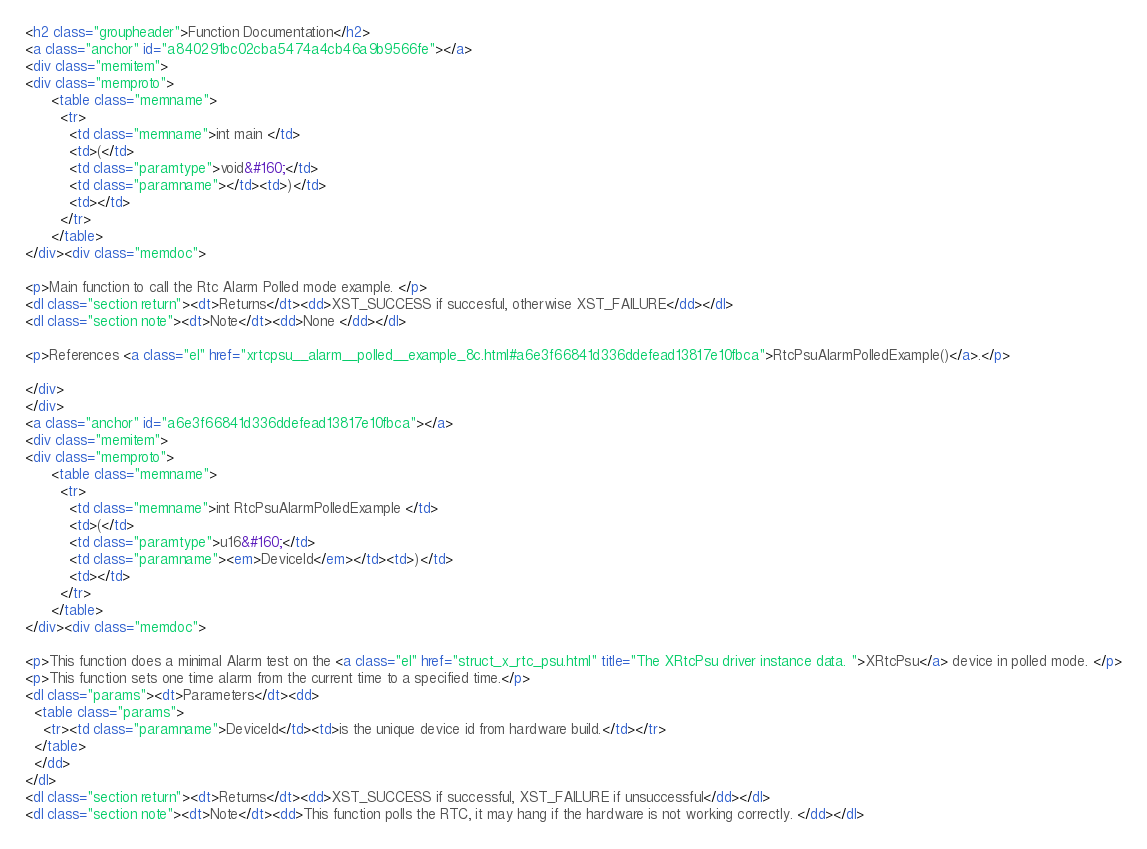<code> <loc_0><loc_0><loc_500><loc_500><_HTML_><h2 class="groupheader">Function Documentation</h2>
<a class="anchor" id="a840291bc02cba5474a4cb46a9b9566fe"></a>
<div class="memitem">
<div class="memproto">
      <table class="memname">
        <tr>
          <td class="memname">int main </td>
          <td>(</td>
          <td class="paramtype">void&#160;</td>
          <td class="paramname"></td><td>)</td>
          <td></td>
        </tr>
      </table>
</div><div class="memdoc">

<p>Main function to call the Rtc Alarm Polled mode example. </p>
<dl class="section return"><dt>Returns</dt><dd>XST_SUCCESS if succesful, otherwise XST_FAILURE</dd></dl>
<dl class="section note"><dt>Note</dt><dd>None </dd></dl>

<p>References <a class="el" href="xrtcpsu__alarm__polled__example_8c.html#a6e3f66841d336ddefead13817e10fbca">RtcPsuAlarmPolledExample()</a>.</p>

</div>
</div>
<a class="anchor" id="a6e3f66841d336ddefead13817e10fbca"></a>
<div class="memitem">
<div class="memproto">
      <table class="memname">
        <tr>
          <td class="memname">int RtcPsuAlarmPolledExample </td>
          <td>(</td>
          <td class="paramtype">u16&#160;</td>
          <td class="paramname"><em>DeviceId</em></td><td>)</td>
          <td></td>
        </tr>
      </table>
</div><div class="memdoc">

<p>This function does a minimal Alarm test on the <a class="el" href="struct_x_rtc_psu.html" title="The XRtcPsu driver instance data. ">XRtcPsu</a> device in polled mode. </p>
<p>This function sets one time alarm from the current time to a specified time.</p>
<dl class="params"><dt>Parameters</dt><dd>
  <table class="params">
    <tr><td class="paramname">DeviceId</td><td>is the unique device id from hardware build.</td></tr>
  </table>
  </dd>
</dl>
<dl class="section return"><dt>Returns</dt><dd>XST_SUCCESS if successful, XST_FAILURE if unsuccessful</dd></dl>
<dl class="section note"><dt>Note</dt><dd>This function polls the RTC, it may hang if the hardware is not working correctly. </dd></dl>
</code> 